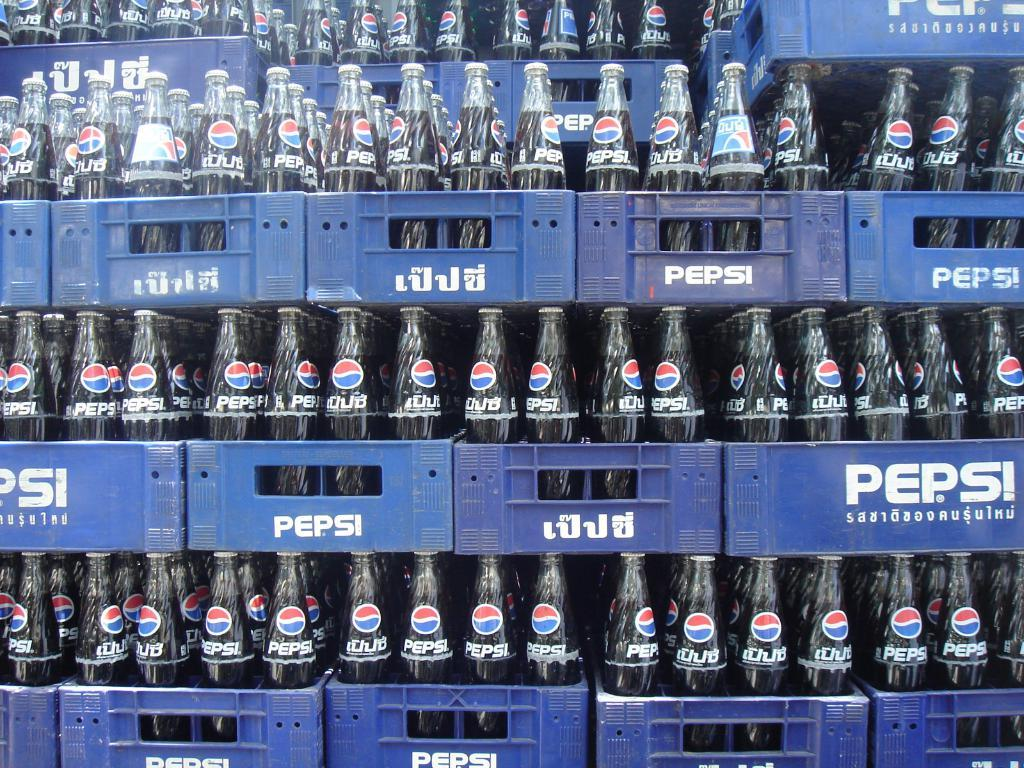<image>
Summarize the visual content of the image. Several crates stacked on top of each other containing bottles of Pepsi 